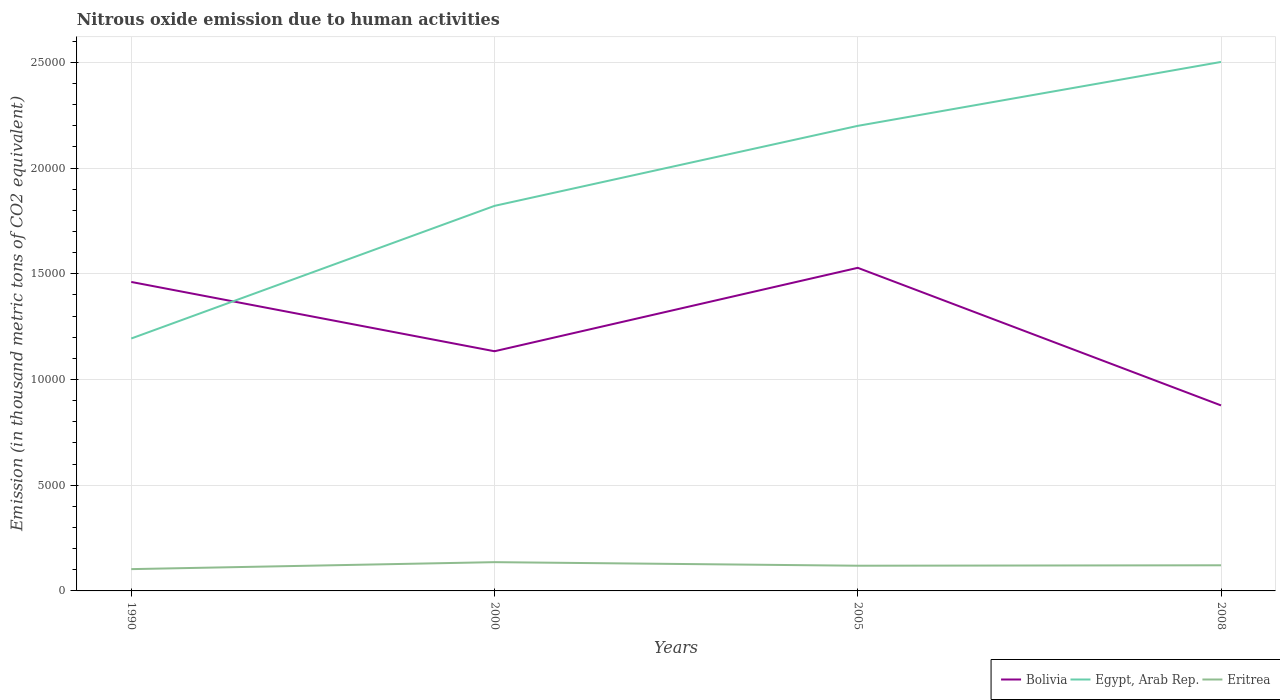How many different coloured lines are there?
Your answer should be compact. 3. Does the line corresponding to Bolivia intersect with the line corresponding to Egypt, Arab Rep.?
Offer a very short reply. Yes. Is the number of lines equal to the number of legend labels?
Offer a terse response. Yes. Across all years, what is the maximum amount of nitrous oxide emitted in Egypt, Arab Rep.?
Offer a very short reply. 1.19e+04. In which year was the amount of nitrous oxide emitted in Bolivia maximum?
Your response must be concise. 2008. What is the total amount of nitrous oxide emitted in Egypt, Arab Rep. in the graph?
Offer a very short reply. -6272.2. What is the difference between the highest and the second highest amount of nitrous oxide emitted in Bolivia?
Offer a very short reply. 6506.5. How many years are there in the graph?
Provide a succinct answer. 4. What is the difference between two consecutive major ticks on the Y-axis?
Offer a very short reply. 5000. Are the values on the major ticks of Y-axis written in scientific E-notation?
Provide a succinct answer. No. Does the graph contain any zero values?
Keep it short and to the point. No. Where does the legend appear in the graph?
Offer a terse response. Bottom right. How are the legend labels stacked?
Your response must be concise. Horizontal. What is the title of the graph?
Make the answer very short. Nitrous oxide emission due to human activities. Does "Myanmar" appear as one of the legend labels in the graph?
Provide a short and direct response. No. What is the label or title of the Y-axis?
Provide a succinct answer. Emission (in thousand metric tons of CO2 equivalent). What is the Emission (in thousand metric tons of CO2 equivalent) in Bolivia in 1990?
Provide a short and direct response. 1.46e+04. What is the Emission (in thousand metric tons of CO2 equivalent) in Egypt, Arab Rep. in 1990?
Your answer should be compact. 1.19e+04. What is the Emission (in thousand metric tons of CO2 equivalent) in Eritrea in 1990?
Provide a short and direct response. 1030.6. What is the Emission (in thousand metric tons of CO2 equivalent) in Bolivia in 2000?
Provide a succinct answer. 1.13e+04. What is the Emission (in thousand metric tons of CO2 equivalent) in Egypt, Arab Rep. in 2000?
Give a very brief answer. 1.82e+04. What is the Emission (in thousand metric tons of CO2 equivalent) of Eritrea in 2000?
Offer a terse response. 1360.3. What is the Emission (in thousand metric tons of CO2 equivalent) of Bolivia in 2005?
Make the answer very short. 1.53e+04. What is the Emission (in thousand metric tons of CO2 equivalent) in Egypt, Arab Rep. in 2005?
Offer a terse response. 2.20e+04. What is the Emission (in thousand metric tons of CO2 equivalent) in Eritrea in 2005?
Your response must be concise. 1191.7. What is the Emission (in thousand metric tons of CO2 equivalent) of Bolivia in 2008?
Keep it short and to the point. 8773. What is the Emission (in thousand metric tons of CO2 equivalent) of Egypt, Arab Rep. in 2008?
Your answer should be compact. 2.50e+04. What is the Emission (in thousand metric tons of CO2 equivalent) in Eritrea in 2008?
Your answer should be very brief. 1212.8. Across all years, what is the maximum Emission (in thousand metric tons of CO2 equivalent) in Bolivia?
Give a very brief answer. 1.53e+04. Across all years, what is the maximum Emission (in thousand metric tons of CO2 equivalent) in Egypt, Arab Rep.?
Your answer should be compact. 2.50e+04. Across all years, what is the maximum Emission (in thousand metric tons of CO2 equivalent) in Eritrea?
Your response must be concise. 1360.3. Across all years, what is the minimum Emission (in thousand metric tons of CO2 equivalent) of Bolivia?
Your answer should be very brief. 8773. Across all years, what is the minimum Emission (in thousand metric tons of CO2 equivalent) in Egypt, Arab Rep.?
Offer a very short reply. 1.19e+04. Across all years, what is the minimum Emission (in thousand metric tons of CO2 equivalent) in Eritrea?
Offer a terse response. 1030.6. What is the total Emission (in thousand metric tons of CO2 equivalent) in Bolivia in the graph?
Give a very brief answer. 5.00e+04. What is the total Emission (in thousand metric tons of CO2 equivalent) of Egypt, Arab Rep. in the graph?
Your answer should be very brief. 7.72e+04. What is the total Emission (in thousand metric tons of CO2 equivalent) of Eritrea in the graph?
Provide a succinct answer. 4795.4. What is the difference between the Emission (in thousand metric tons of CO2 equivalent) of Bolivia in 1990 and that in 2000?
Your answer should be very brief. 3277.5. What is the difference between the Emission (in thousand metric tons of CO2 equivalent) in Egypt, Arab Rep. in 1990 and that in 2000?
Your answer should be compact. -6272.2. What is the difference between the Emission (in thousand metric tons of CO2 equivalent) of Eritrea in 1990 and that in 2000?
Your answer should be very brief. -329.7. What is the difference between the Emission (in thousand metric tons of CO2 equivalent) of Bolivia in 1990 and that in 2005?
Offer a very short reply. -667.9. What is the difference between the Emission (in thousand metric tons of CO2 equivalent) of Egypt, Arab Rep. in 1990 and that in 2005?
Ensure brevity in your answer.  -1.01e+04. What is the difference between the Emission (in thousand metric tons of CO2 equivalent) of Eritrea in 1990 and that in 2005?
Offer a terse response. -161.1. What is the difference between the Emission (in thousand metric tons of CO2 equivalent) of Bolivia in 1990 and that in 2008?
Make the answer very short. 5838.6. What is the difference between the Emission (in thousand metric tons of CO2 equivalent) in Egypt, Arab Rep. in 1990 and that in 2008?
Give a very brief answer. -1.31e+04. What is the difference between the Emission (in thousand metric tons of CO2 equivalent) of Eritrea in 1990 and that in 2008?
Keep it short and to the point. -182.2. What is the difference between the Emission (in thousand metric tons of CO2 equivalent) of Bolivia in 2000 and that in 2005?
Ensure brevity in your answer.  -3945.4. What is the difference between the Emission (in thousand metric tons of CO2 equivalent) in Egypt, Arab Rep. in 2000 and that in 2005?
Provide a succinct answer. -3783.9. What is the difference between the Emission (in thousand metric tons of CO2 equivalent) in Eritrea in 2000 and that in 2005?
Provide a short and direct response. 168.6. What is the difference between the Emission (in thousand metric tons of CO2 equivalent) of Bolivia in 2000 and that in 2008?
Give a very brief answer. 2561.1. What is the difference between the Emission (in thousand metric tons of CO2 equivalent) in Egypt, Arab Rep. in 2000 and that in 2008?
Ensure brevity in your answer.  -6806.9. What is the difference between the Emission (in thousand metric tons of CO2 equivalent) of Eritrea in 2000 and that in 2008?
Your answer should be very brief. 147.5. What is the difference between the Emission (in thousand metric tons of CO2 equivalent) of Bolivia in 2005 and that in 2008?
Provide a short and direct response. 6506.5. What is the difference between the Emission (in thousand metric tons of CO2 equivalent) in Egypt, Arab Rep. in 2005 and that in 2008?
Keep it short and to the point. -3023. What is the difference between the Emission (in thousand metric tons of CO2 equivalent) of Eritrea in 2005 and that in 2008?
Offer a terse response. -21.1. What is the difference between the Emission (in thousand metric tons of CO2 equivalent) in Bolivia in 1990 and the Emission (in thousand metric tons of CO2 equivalent) in Egypt, Arab Rep. in 2000?
Your answer should be very brief. -3597.5. What is the difference between the Emission (in thousand metric tons of CO2 equivalent) of Bolivia in 1990 and the Emission (in thousand metric tons of CO2 equivalent) of Eritrea in 2000?
Keep it short and to the point. 1.33e+04. What is the difference between the Emission (in thousand metric tons of CO2 equivalent) of Egypt, Arab Rep. in 1990 and the Emission (in thousand metric tons of CO2 equivalent) of Eritrea in 2000?
Keep it short and to the point. 1.06e+04. What is the difference between the Emission (in thousand metric tons of CO2 equivalent) of Bolivia in 1990 and the Emission (in thousand metric tons of CO2 equivalent) of Egypt, Arab Rep. in 2005?
Provide a succinct answer. -7381.4. What is the difference between the Emission (in thousand metric tons of CO2 equivalent) in Bolivia in 1990 and the Emission (in thousand metric tons of CO2 equivalent) in Eritrea in 2005?
Provide a short and direct response. 1.34e+04. What is the difference between the Emission (in thousand metric tons of CO2 equivalent) of Egypt, Arab Rep. in 1990 and the Emission (in thousand metric tons of CO2 equivalent) of Eritrea in 2005?
Provide a short and direct response. 1.07e+04. What is the difference between the Emission (in thousand metric tons of CO2 equivalent) of Bolivia in 1990 and the Emission (in thousand metric tons of CO2 equivalent) of Egypt, Arab Rep. in 2008?
Your response must be concise. -1.04e+04. What is the difference between the Emission (in thousand metric tons of CO2 equivalent) of Bolivia in 1990 and the Emission (in thousand metric tons of CO2 equivalent) of Eritrea in 2008?
Your answer should be compact. 1.34e+04. What is the difference between the Emission (in thousand metric tons of CO2 equivalent) in Egypt, Arab Rep. in 1990 and the Emission (in thousand metric tons of CO2 equivalent) in Eritrea in 2008?
Keep it short and to the point. 1.07e+04. What is the difference between the Emission (in thousand metric tons of CO2 equivalent) in Bolivia in 2000 and the Emission (in thousand metric tons of CO2 equivalent) in Egypt, Arab Rep. in 2005?
Give a very brief answer. -1.07e+04. What is the difference between the Emission (in thousand metric tons of CO2 equivalent) in Bolivia in 2000 and the Emission (in thousand metric tons of CO2 equivalent) in Eritrea in 2005?
Offer a very short reply. 1.01e+04. What is the difference between the Emission (in thousand metric tons of CO2 equivalent) of Egypt, Arab Rep. in 2000 and the Emission (in thousand metric tons of CO2 equivalent) of Eritrea in 2005?
Offer a very short reply. 1.70e+04. What is the difference between the Emission (in thousand metric tons of CO2 equivalent) in Bolivia in 2000 and the Emission (in thousand metric tons of CO2 equivalent) in Egypt, Arab Rep. in 2008?
Your response must be concise. -1.37e+04. What is the difference between the Emission (in thousand metric tons of CO2 equivalent) in Bolivia in 2000 and the Emission (in thousand metric tons of CO2 equivalent) in Eritrea in 2008?
Your answer should be very brief. 1.01e+04. What is the difference between the Emission (in thousand metric tons of CO2 equivalent) in Egypt, Arab Rep. in 2000 and the Emission (in thousand metric tons of CO2 equivalent) in Eritrea in 2008?
Provide a succinct answer. 1.70e+04. What is the difference between the Emission (in thousand metric tons of CO2 equivalent) of Bolivia in 2005 and the Emission (in thousand metric tons of CO2 equivalent) of Egypt, Arab Rep. in 2008?
Your answer should be very brief. -9736.5. What is the difference between the Emission (in thousand metric tons of CO2 equivalent) of Bolivia in 2005 and the Emission (in thousand metric tons of CO2 equivalent) of Eritrea in 2008?
Keep it short and to the point. 1.41e+04. What is the difference between the Emission (in thousand metric tons of CO2 equivalent) of Egypt, Arab Rep. in 2005 and the Emission (in thousand metric tons of CO2 equivalent) of Eritrea in 2008?
Offer a very short reply. 2.08e+04. What is the average Emission (in thousand metric tons of CO2 equivalent) in Bolivia per year?
Offer a very short reply. 1.25e+04. What is the average Emission (in thousand metric tons of CO2 equivalent) in Egypt, Arab Rep. per year?
Make the answer very short. 1.93e+04. What is the average Emission (in thousand metric tons of CO2 equivalent) in Eritrea per year?
Ensure brevity in your answer.  1198.85. In the year 1990, what is the difference between the Emission (in thousand metric tons of CO2 equivalent) of Bolivia and Emission (in thousand metric tons of CO2 equivalent) of Egypt, Arab Rep.?
Give a very brief answer. 2674.7. In the year 1990, what is the difference between the Emission (in thousand metric tons of CO2 equivalent) in Bolivia and Emission (in thousand metric tons of CO2 equivalent) in Eritrea?
Keep it short and to the point. 1.36e+04. In the year 1990, what is the difference between the Emission (in thousand metric tons of CO2 equivalent) of Egypt, Arab Rep. and Emission (in thousand metric tons of CO2 equivalent) of Eritrea?
Provide a short and direct response. 1.09e+04. In the year 2000, what is the difference between the Emission (in thousand metric tons of CO2 equivalent) in Bolivia and Emission (in thousand metric tons of CO2 equivalent) in Egypt, Arab Rep.?
Ensure brevity in your answer.  -6875. In the year 2000, what is the difference between the Emission (in thousand metric tons of CO2 equivalent) of Bolivia and Emission (in thousand metric tons of CO2 equivalent) of Eritrea?
Offer a very short reply. 9973.8. In the year 2000, what is the difference between the Emission (in thousand metric tons of CO2 equivalent) of Egypt, Arab Rep. and Emission (in thousand metric tons of CO2 equivalent) of Eritrea?
Offer a terse response. 1.68e+04. In the year 2005, what is the difference between the Emission (in thousand metric tons of CO2 equivalent) of Bolivia and Emission (in thousand metric tons of CO2 equivalent) of Egypt, Arab Rep.?
Provide a succinct answer. -6713.5. In the year 2005, what is the difference between the Emission (in thousand metric tons of CO2 equivalent) in Bolivia and Emission (in thousand metric tons of CO2 equivalent) in Eritrea?
Provide a short and direct response. 1.41e+04. In the year 2005, what is the difference between the Emission (in thousand metric tons of CO2 equivalent) in Egypt, Arab Rep. and Emission (in thousand metric tons of CO2 equivalent) in Eritrea?
Your answer should be compact. 2.08e+04. In the year 2008, what is the difference between the Emission (in thousand metric tons of CO2 equivalent) of Bolivia and Emission (in thousand metric tons of CO2 equivalent) of Egypt, Arab Rep.?
Make the answer very short. -1.62e+04. In the year 2008, what is the difference between the Emission (in thousand metric tons of CO2 equivalent) in Bolivia and Emission (in thousand metric tons of CO2 equivalent) in Eritrea?
Offer a terse response. 7560.2. In the year 2008, what is the difference between the Emission (in thousand metric tons of CO2 equivalent) of Egypt, Arab Rep. and Emission (in thousand metric tons of CO2 equivalent) of Eritrea?
Offer a very short reply. 2.38e+04. What is the ratio of the Emission (in thousand metric tons of CO2 equivalent) in Bolivia in 1990 to that in 2000?
Offer a terse response. 1.29. What is the ratio of the Emission (in thousand metric tons of CO2 equivalent) of Egypt, Arab Rep. in 1990 to that in 2000?
Make the answer very short. 0.66. What is the ratio of the Emission (in thousand metric tons of CO2 equivalent) in Eritrea in 1990 to that in 2000?
Make the answer very short. 0.76. What is the ratio of the Emission (in thousand metric tons of CO2 equivalent) of Bolivia in 1990 to that in 2005?
Your answer should be compact. 0.96. What is the ratio of the Emission (in thousand metric tons of CO2 equivalent) of Egypt, Arab Rep. in 1990 to that in 2005?
Provide a short and direct response. 0.54. What is the ratio of the Emission (in thousand metric tons of CO2 equivalent) of Eritrea in 1990 to that in 2005?
Offer a very short reply. 0.86. What is the ratio of the Emission (in thousand metric tons of CO2 equivalent) in Bolivia in 1990 to that in 2008?
Keep it short and to the point. 1.67. What is the ratio of the Emission (in thousand metric tons of CO2 equivalent) of Egypt, Arab Rep. in 1990 to that in 2008?
Give a very brief answer. 0.48. What is the ratio of the Emission (in thousand metric tons of CO2 equivalent) in Eritrea in 1990 to that in 2008?
Keep it short and to the point. 0.85. What is the ratio of the Emission (in thousand metric tons of CO2 equivalent) of Bolivia in 2000 to that in 2005?
Give a very brief answer. 0.74. What is the ratio of the Emission (in thousand metric tons of CO2 equivalent) in Egypt, Arab Rep. in 2000 to that in 2005?
Make the answer very short. 0.83. What is the ratio of the Emission (in thousand metric tons of CO2 equivalent) of Eritrea in 2000 to that in 2005?
Make the answer very short. 1.14. What is the ratio of the Emission (in thousand metric tons of CO2 equivalent) of Bolivia in 2000 to that in 2008?
Give a very brief answer. 1.29. What is the ratio of the Emission (in thousand metric tons of CO2 equivalent) of Egypt, Arab Rep. in 2000 to that in 2008?
Provide a short and direct response. 0.73. What is the ratio of the Emission (in thousand metric tons of CO2 equivalent) in Eritrea in 2000 to that in 2008?
Provide a short and direct response. 1.12. What is the ratio of the Emission (in thousand metric tons of CO2 equivalent) in Bolivia in 2005 to that in 2008?
Make the answer very short. 1.74. What is the ratio of the Emission (in thousand metric tons of CO2 equivalent) of Egypt, Arab Rep. in 2005 to that in 2008?
Your response must be concise. 0.88. What is the ratio of the Emission (in thousand metric tons of CO2 equivalent) of Eritrea in 2005 to that in 2008?
Your answer should be very brief. 0.98. What is the difference between the highest and the second highest Emission (in thousand metric tons of CO2 equivalent) in Bolivia?
Give a very brief answer. 667.9. What is the difference between the highest and the second highest Emission (in thousand metric tons of CO2 equivalent) in Egypt, Arab Rep.?
Your response must be concise. 3023. What is the difference between the highest and the second highest Emission (in thousand metric tons of CO2 equivalent) of Eritrea?
Give a very brief answer. 147.5. What is the difference between the highest and the lowest Emission (in thousand metric tons of CO2 equivalent) in Bolivia?
Make the answer very short. 6506.5. What is the difference between the highest and the lowest Emission (in thousand metric tons of CO2 equivalent) in Egypt, Arab Rep.?
Give a very brief answer. 1.31e+04. What is the difference between the highest and the lowest Emission (in thousand metric tons of CO2 equivalent) in Eritrea?
Your answer should be compact. 329.7. 